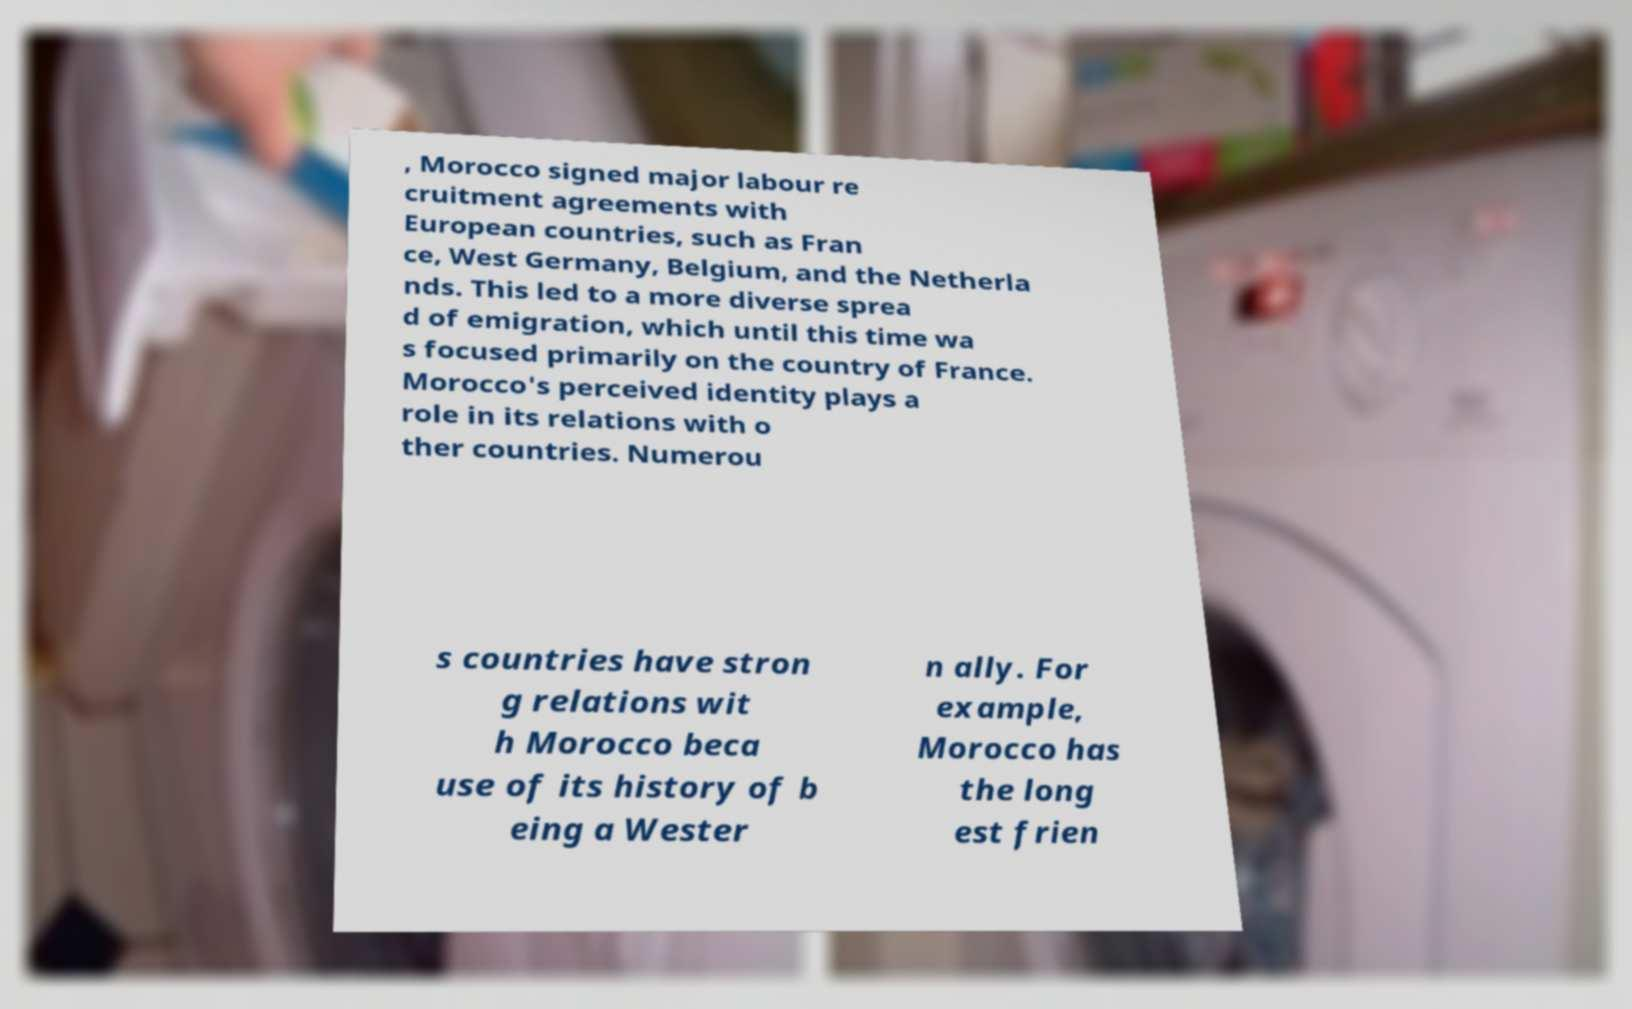There's text embedded in this image that I need extracted. Can you transcribe it verbatim? , Morocco signed major labour re cruitment agreements with European countries, such as Fran ce, West Germany, Belgium, and the Netherla nds. This led to a more diverse sprea d of emigration, which until this time wa s focused primarily on the country of France. Morocco's perceived identity plays a role in its relations with o ther countries. Numerou s countries have stron g relations wit h Morocco beca use of its history of b eing a Wester n ally. For example, Morocco has the long est frien 